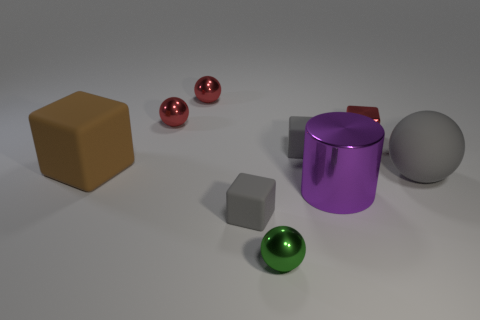What textures are visible on the objects? The objects have a smooth texture with a matte finish, providing a sense of softness to the surfaces that contrast with the sharp edges of some objects like the cube and the cylinder. 